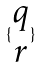Convert formula to latex. <formula><loc_0><loc_0><loc_500><loc_500>\{ \begin{matrix} q \\ r \end{matrix} \}</formula> 